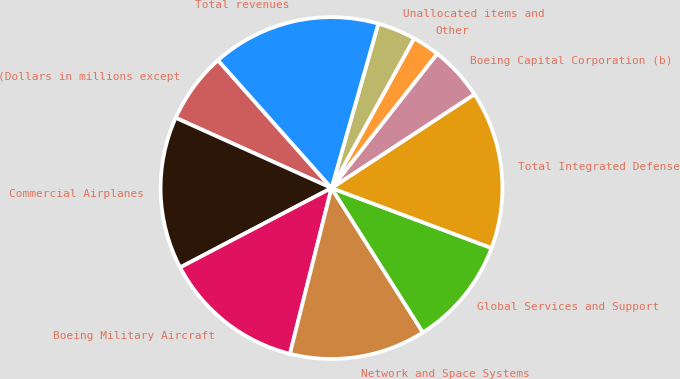Convert chart. <chart><loc_0><loc_0><loc_500><loc_500><pie_chart><fcel>(Dollars in millions except<fcel>Commercial Airplanes<fcel>Boeing Military Aircraft<fcel>Network and Space Systems<fcel>Global Services and Support<fcel>Total Integrated Defense<fcel>Boeing Capital Corporation (b)<fcel>Other<fcel>Unallocated items and<fcel>Total revenues<nl><fcel>6.7%<fcel>14.43%<fcel>13.4%<fcel>12.89%<fcel>10.31%<fcel>14.95%<fcel>5.15%<fcel>2.58%<fcel>3.61%<fcel>15.98%<nl></chart> 